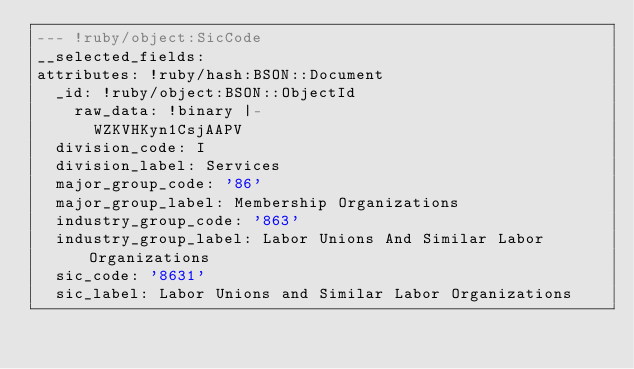Convert code to text. <code><loc_0><loc_0><loc_500><loc_500><_YAML_>--- !ruby/object:SicCode
__selected_fields: 
attributes: !ruby/hash:BSON::Document
  _id: !ruby/object:BSON::ObjectId
    raw_data: !binary |-
      WZKVHKyn1CsjAAPV
  division_code: I
  division_label: Services
  major_group_code: '86'
  major_group_label: Membership Organizations
  industry_group_code: '863'
  industry_group_label: Labor Unions And Similar Labor Organizations
  sic_code: '8631'
  sic_label: Labor Unions and Similar Labor Organizations
</code> 